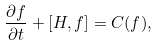<formula> <loc_0><loc_0><loc_500><loc_500>\frac { \partial f } { \partial t } + [ H , f ] = C ( f ) ,</formula> 